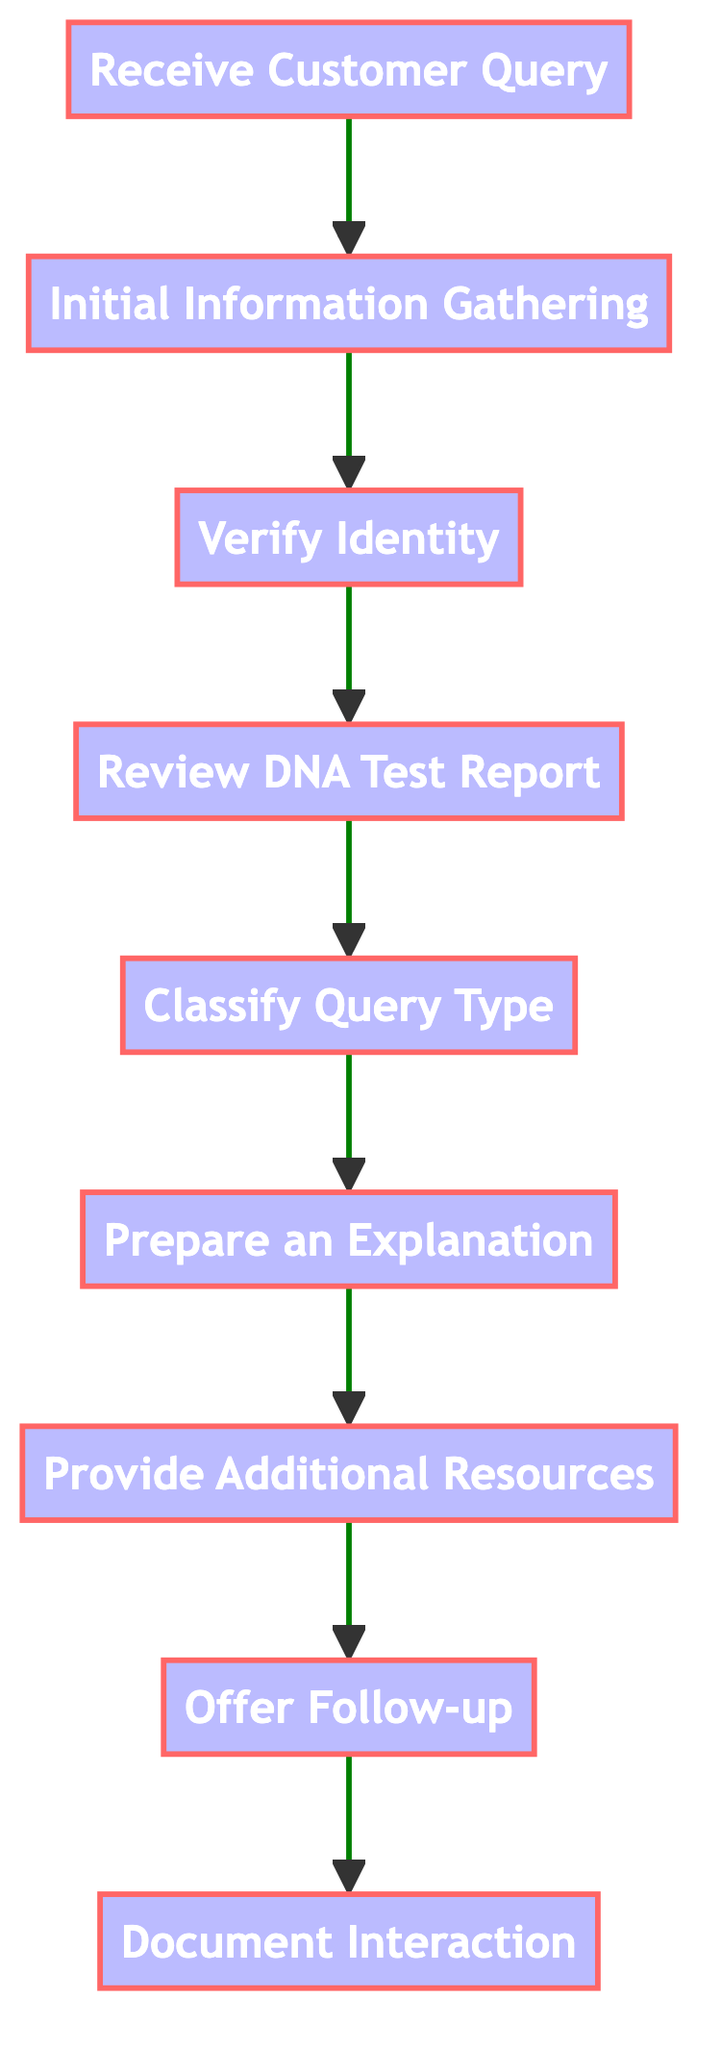What is the first step in the flowchart? The first step in the flowchart is to "Receive Customer Query." This is the initial point of contact where the customer reaches out with a question about their DNA test results.
Answer: Receive Customer Query How many nodes are present in the diagram? The diagram contains nine nodes, which represent different steps in the procedures for responding to customer queries about DNA test results.
Answer: 9 What follows after "Verify Identity"? The step that follows "Verify Identity" is "Review DNA Test Report." This indicates that once the customer's identity is confirmed, the next action is to examine the DNA test results.
Answer: Review DNA Test Report Which step involves crafting a response? The step that involves crafting a response is "Prepare an Explanation." This is where a clear and concise explanation is drafted based on the classified query type.
Answer: Prepare an Explanation What category does "Classify Query Type" belong to? "Classify Query Type" belongs to the category of information processing, as it requires determining the nature of the query related to ancestry, health risks, etc.
Answer: Information Processing What is the final step shown in the flowchart? The final step shown in the flowchart is "Document Interaction." This step involves logging the customer query and the response provided for future reference and quality control.
Answer: Document Interaction How many types of queries can be classified? While the exact number is not specified, the flowchart implies there could be several categories, including but not limited to ancestry, health risks, carrier status, and traits, as mentioned in the "Classify Query Type" step.
Answer: Several (implied multiple) What resource is provided following "Prepare an Explanation"? The resource provided following "Prepare an Explanation" is "Provide Additional Resources." This step includes sharing links to scientific articles and other materials for clarification.
Answer: Provide Additional Resources What action is advised for the customer after the initial explanation? The action advised for the customer after the initial explanation is to "Offer Follow-up." This informs them that they can reach out again with additional questions or concerns.
Answer: Offer Follow-up 